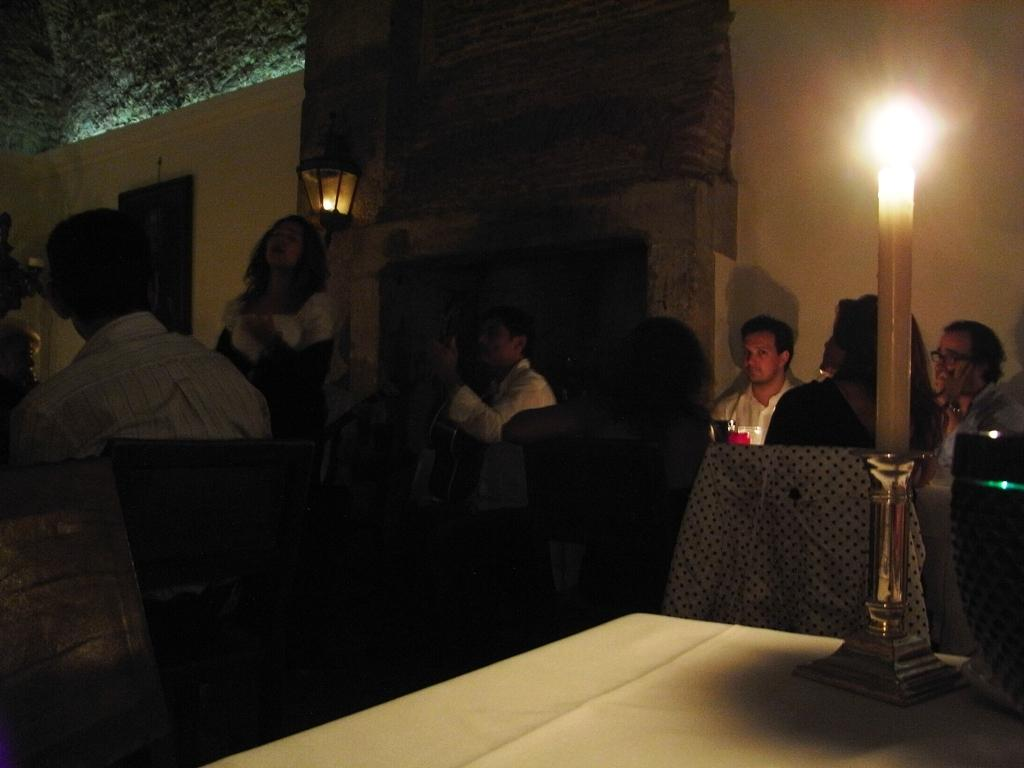What is placed on the white table in the image? There is a white candle on the white table. What can be seen behind the table? People are seated on chairs behind the table, and there is a person standing at the back. What is the color of the wall at the back? The wall at the back is white. What type of education can be seen being taught in the image? There is no indication of any educational activity in the image. What type of wool is being used to create the print on the wall? There is no print on the wall in the image, and no wool is mentioned or visible. 